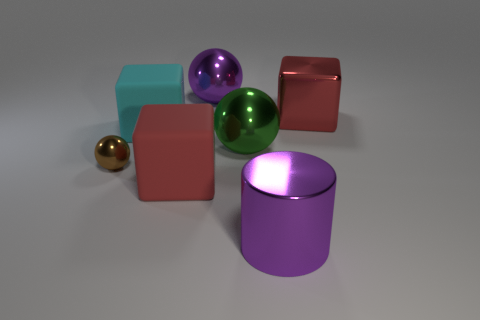Subtract all shiny blocks. How many blocks are left? 2 Add 2 big red shiny things. How many objects exist? 9 Subtract all brown spheres. How many spheres are left? 2 Subtract 2 blocks. How many blocks are left? 1 Subtract all purple balls. Subtract all purple cylinders. How many balls are left? 2 Subtract 0 red cylinders. How many objects are left? 7 Subtract all cylinders. How many objects are left? 6 Subtract all red cylinders. How many gray cubes are left? 0 Subtract all big purple shiny cylinders. Subtract all blocks. How many objects are left? 3 Add 6 green spheres. How many green spheres are left? 7 